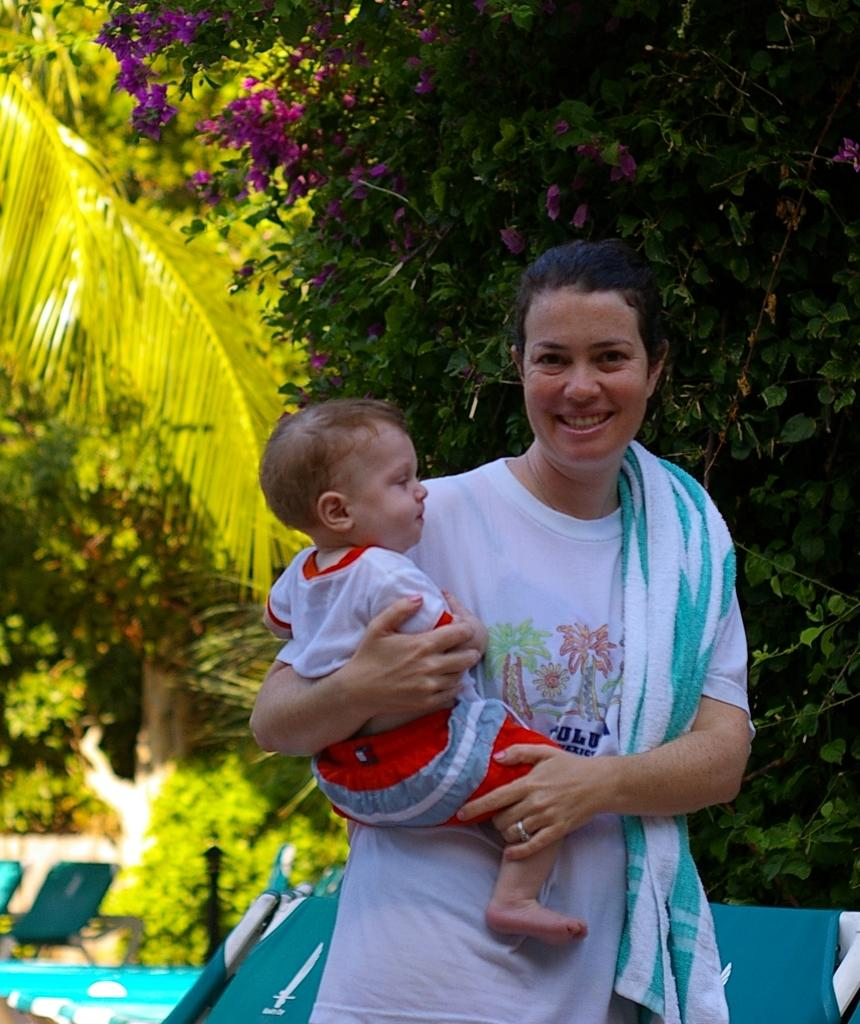Who is present in the image? There is a woman in the image. What is the woman doing in the image? The woman is smiling and holding a baby. What is the woman wearing or carrying in the image? The woman has a towel on her shoulder. What can be seen in the background of the image? There are chairs, trees, and plants visible in the background of the image. What type of comb is the woman using on the baby's toes in the image? There is no comb or reference to the baby's toes in the image. What type of blade is visible in the woman's hand in the image? There is no blade visible in the woman's hand in the image. 